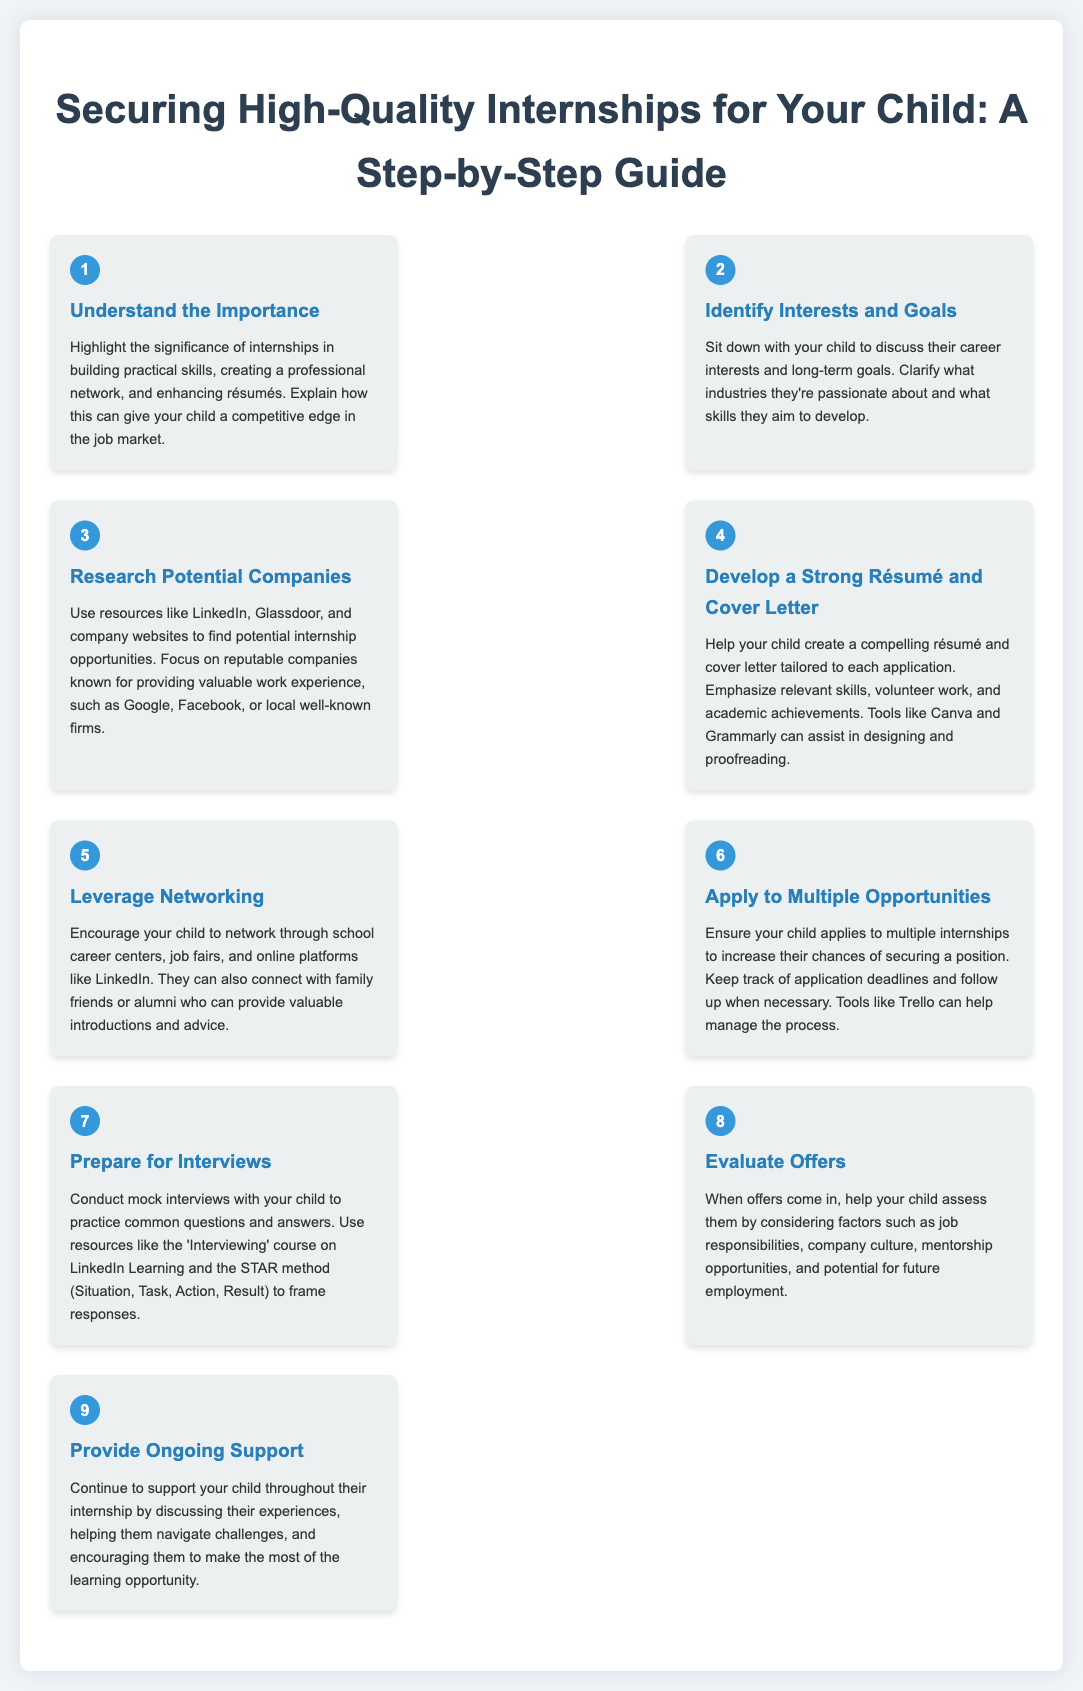What is step number three? Step three focuses on researching potential companies for internships.
Answer: Research Potential Companies How many steps are there in the guide? The document lists a total of nine steps in the process for securing internships.
Answer: Nine What is the title of step five? Step five is titled "Leverage Networking" which emphasizes the importance of networking for securing internships.
Answer: Leverage Networking What should be emphasized in a résumé and cover letter? The document suggests emphasizing relevant skills, volunteer work, and academic achievements.
Answer: Relevant skills, volunteer work, and academic achievements What resources can help manage the internship application process? The document mentions tools like Trello for managing the process of applications.
Answer: Trello What is the STAR method used for in step seven? The STAR method is recommended for framing responses during mock interview practice.
Answer: Framing responses What is the first step that highlights internship significance? The first step is "Understand the Importance" which discusses the benefits of internships.
Answer: Understand the Importance What factors should be considered when evaluating internship offers? Factors include job responsibilities, company culture, mentorship opportunities, and potential for future employment.
Answer: Job responsibilities, company culture, mentorship opportunities, and potential for future employment 